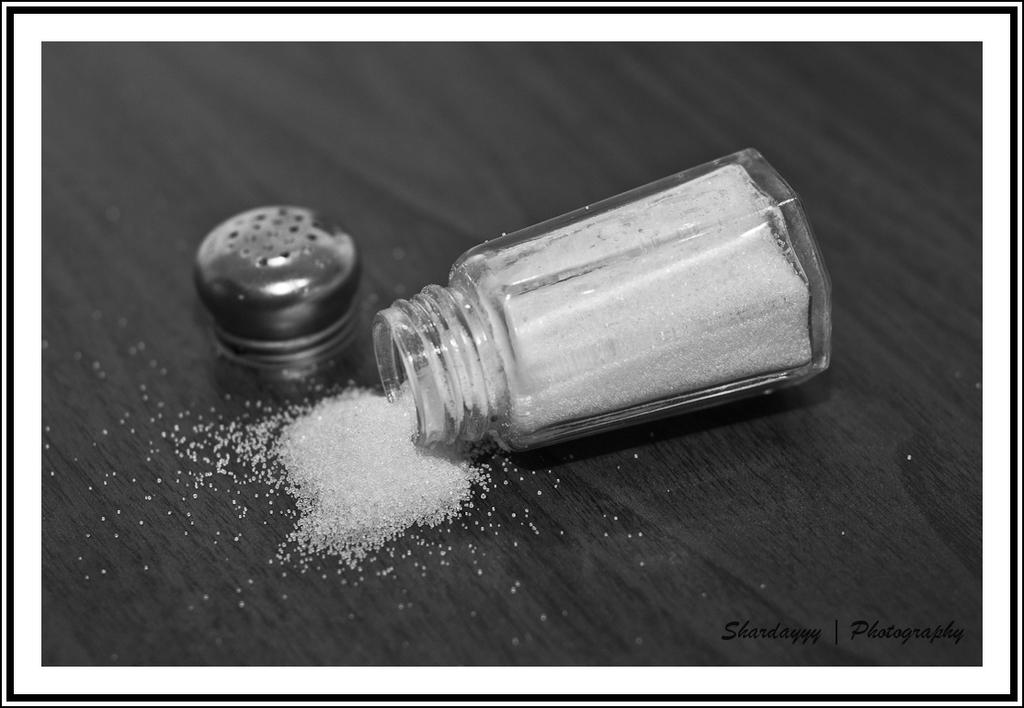What is the color scheme of the image? The image is black and white. What is inside the jar that is visible in the image? There is a jar containing sugar in the image. What object is also present in the image, related to the jar? There is a cap in the image. Where are the jar and cap located in the image? The jar and cap are on a table in the image. What can be found at the bottom of the image? There is some text at the bottom of the image. How many fangs can be seen on the jar in the image? There are no fangs present on the jar in the image. What type of authority is depicted in the image? There is no depiction of authority in the image; it features a jar of sugar, a cap, and some text. 